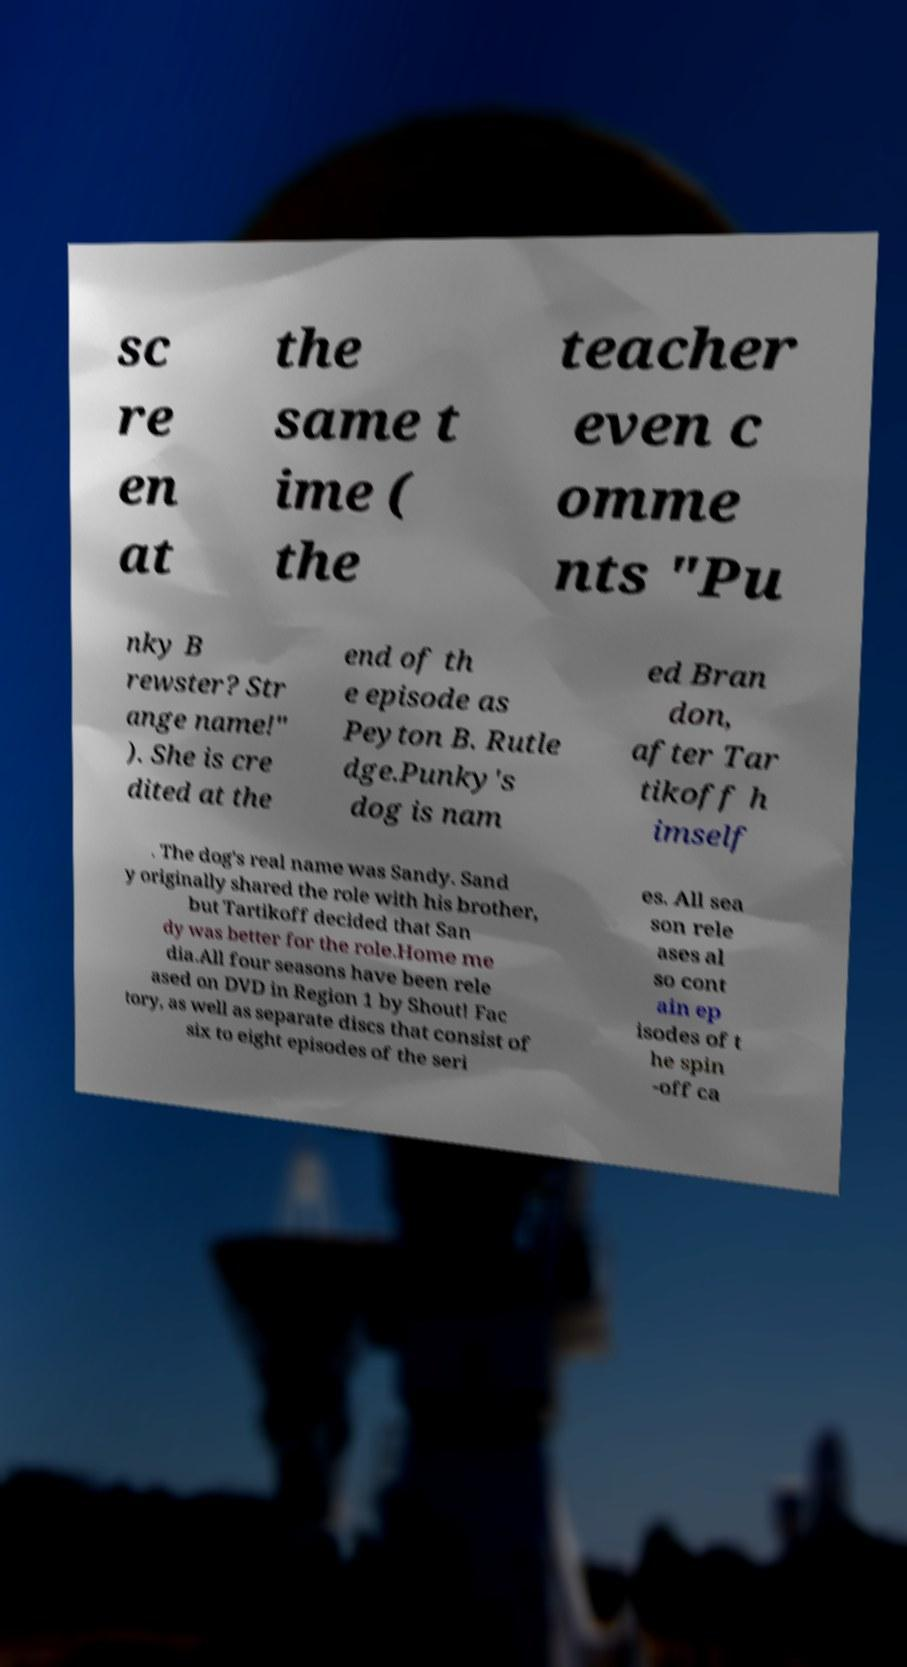Can you read and provide the text displayed in the image?This photo seems to have some interesting text. Can you extract and type it out for me? sc re en at the same t ime ( the teacher even c omme nts "Pu nky B rewster? Str ange name!" ). She is cre dited at the end of th e episode as Peyton B. Rutle dge.Punky's dog is nam ed Bran don, after Tar tikoff h imself . The dog's real name was Sandy. Sand y originally shared the role with his brother, but Tartikoff decided that San dy was better for the role.Home me dia.All four seasons have been rele ased on DVD in Region 1 by Shout! Fac tory, as well as separate discs that consist of six to eight episodes of the seri es. All sea son rele ases al so cont ain ep isodes of t he spin -off ca 